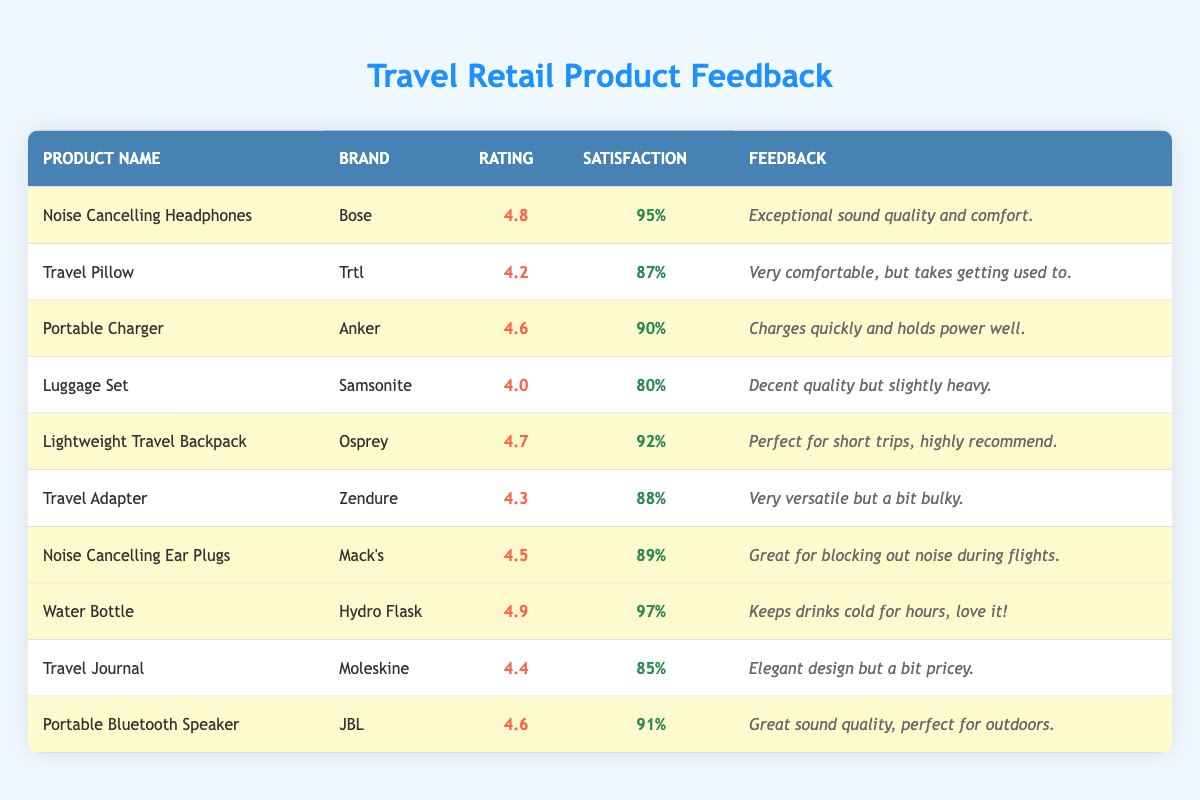What is the highest-rated product in the table? By comparing the customer ratings for all products listed in the table, the highest rating is 4.9, which corresponds to the "Water Bottle" by Hydro Flask.
Answer: Water Bottle Which product has the highest satisfaction percentage? The satisfaction percentages are listed next to each product, and the highest percentage is 97%, which is associated with the "Water Bottle" by Hydro Flask.
Answer: Water Bottle What is the average customer rating of all highlighted products? The highlighted products include Noise Cancelling Headphones (4.8), Portable Charger (4.6), Lightweight Travel Backpack (4.7), Noise Cancelling Ear Plugs (4.5), Water Bottle (4.9), and Portable Bluetooth Speaker (4.6). Adding these ratings gives 4.8 + 4.6 + 4.7 + 4.5 + 4.9 + 4.6 = 29.1. There are 6 products, so the average rating is 29.1 / 6 = 4.85.
Answer: 4.85 Is the customer satisfaction percentage for the Travel Pillow above 85%? The satisfaction percentage for the Travel Pillow is 87%, which is indeed above 85%.
Answer: Yes How many products have a customer rating of 4.5 or higher? By checking each product’s customer rating, four products have a rating 4.5 or higher: Noise Cancelling Headphones (4.8), Portable Charger (4.6), Lightweight Travel Backpack (4.7), Noise Cancelling Ear Plugs (4.5), Water Bottle (4.9), and Portable Bluetooth Speaker (4.6). That makes a total of 6 products.
Answer: 6 What is the difference in satisfaction percentage between the Noise Cancelling Ear Plugs and the Luggage Set? The satisfaction percentage for the Noise Cancelling Ear Plugs is 89% and for the Luggage Set is 80%. The difference is calculated as 89% - 80% = 9%.
Answer: 9% Which product has the best customer feedback comment? The comments for each product suggest fondness for several products, but the standout comment is "Keeps drinks cold for hours, love it!" for the Water Bottle, indicating extremely positive feedback.
Answer: Water Bottle Is the customer rating for the Portable Bluetooth Speaker higher than the Travel Adapter's rating? The Portable Bluetooth Speaker has a rating of 4.6, while the Travel Adapter has a rating of 4.3. Since 4.6 is greater than 4.3, the statement is true.
Answer: Yes What is the lowest customer rating among highlighted products? The highlighted products are assessed: the ratings are 4.8, 4.6, 4.7, 4.5, 4.9, and 4.6. The lowest rating among these is 4.5 for the Noise Cancelling Ear Plugs.
Answer: 4.5 If we consider only the products with a satisfaction percentage above 90%, how many are there? Checking the satisfaction percentages: Water Bottle (97%), Lightweight Travel Backpack (92%), and Portable Bluetooth Speaker (91%) are all above 90%. Thus, there are 3 products with a satisfaction percentage above 90%.
Answer: 3 